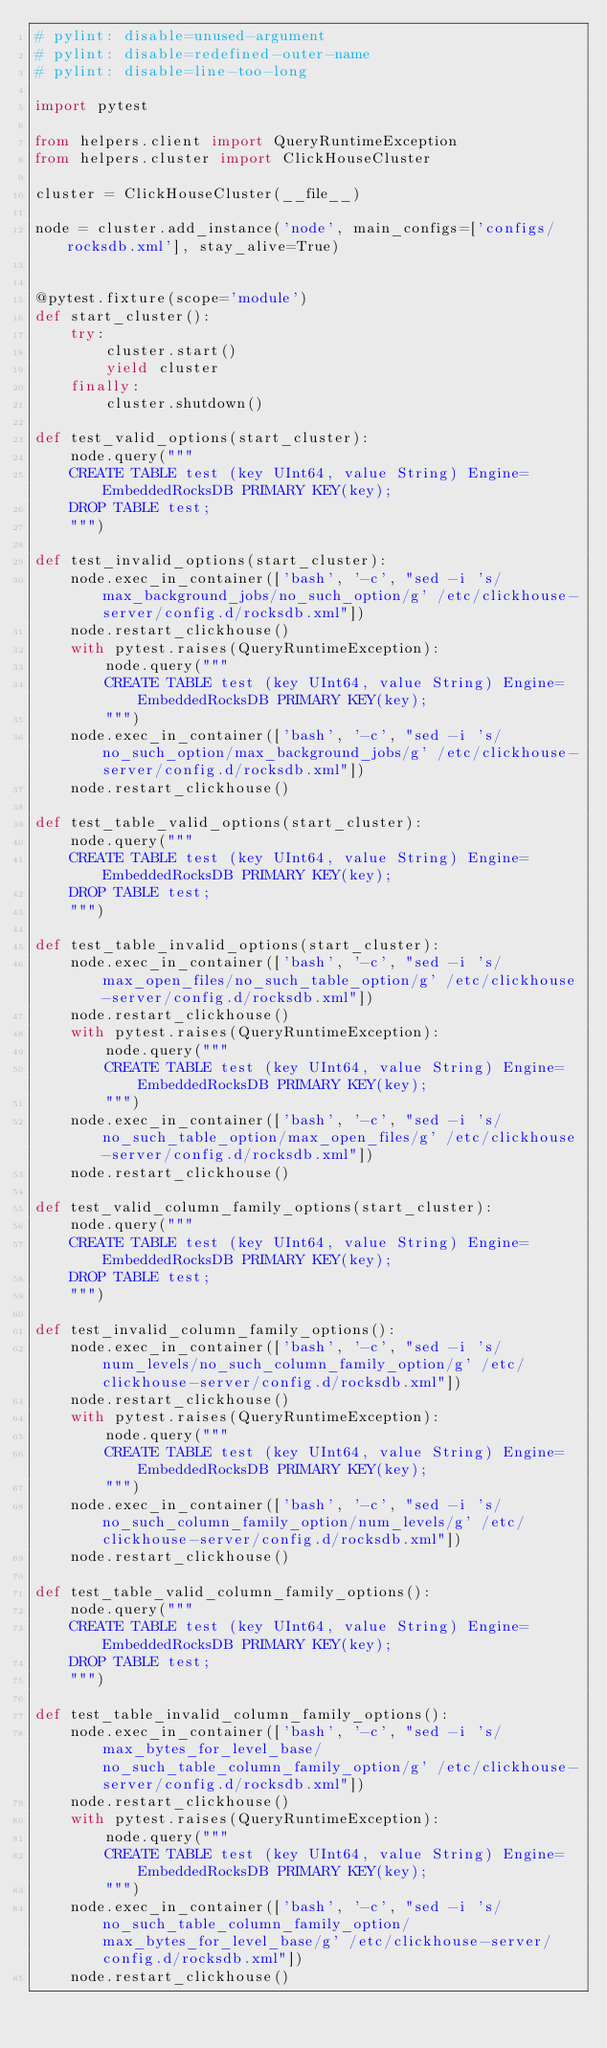<code> <loc_0><loc_0><loc_500><loc_500><_Python_># pylint: disable=unused-argument
# pylint: disable=redefined-outer-name
# pylint: disable=line-too-long

import pytest

from helpers.client import QueryRuntimeException
from helpers.cluster import ClickHouseCluster

cluster = ClickHouseCluster(__file__)

node = cluster.add_instance('node', main_configs=['configs/rocksdb.xml'], stay_alive=True)


@pytest.fixture(scope='module')
def start_cluster():
    try:
        cluster.start()
        yield cluster
    finally:
        cluster.shutdown()

def test_valid_options(start_cluster):
    node.query("""
    CREATE TABLE test (key UInt64, value String) Engine=EmbeddedRocksDB PRIMARY KEY(key);
    DROP TABLE test;
    """)

def test_invalid_options(start_cluster):
    node.exec_in_container(['bash', '-c', "sed -i 's/max_background_jobs/no_such_option/g' /etc/clickhouse-server/config.d/rocksdb.xml"])
    node.restart_clickhouse()
    with pytest.raises(QueryRuntimeException):
        node.query("""
        CREATE TABLE test (key UInt64, value String) Engine=EmbeddedRocksDB PRIMARY KEY(key);
        """)
    node.exec_in_container(['bash', '-c', "sed -i 's/no_such_option/max_background_jobs/g' /etc/clickhouse-server/config.d/rocksdb.xml"])
    node.restart_clickhouse()

def test_table_valid_options(start_cluster):
    node.query("""
    CREATE TABLE test (key UInt64, value String) Engine=EmbeddedRocksDB PRIMARY KEY(key);
    DROP TABLE test;
    """)

def test_table_invalid_options(start_cluster):
    node.exec_in_container(['bash', '-c', "sed -i 's/max_open_files/no_such_table_option/g' /etc/clickhouse-server/config.d/rocksdb.xml"])
    node.restart_clickhouse()
    with pytest.raises(QueryRuntimeException):
        node.query("""
        CREATE TABLE test (key UInt64, value String) Engine=EmbeddedRocksDB PRIMARY KEY(key);
        """)
    node.exec_in_container(['bash', '-c', "sed -i 's/no_such_table_option/max_open_files/g' /etc/clickhouse-server/config.d/rocksdb.xml"])
    node.restart_clickhouse()

def test_valid_column_family_options(start_cluster):
    node.query("""
    CREATE TABLE test (key UInt64, value String) Engine=EmbeddedRocksDB PRIMARY KEY(key);
    DROP TABLE test;
    """)

def test_invalid_column_family_options():
    node.exec_in_container(['bash', '-c', "sed -i 's/num_levels/no_such_column_family_option/g' /etc/clickhouse-server/config.d/rocksdb.xml"])
    node.restart_clickhouse()
    with pytest.raises(QueryRuntimeException):
        node.query("""
        CREATE TABLE test (key UInt64, value String) Engine=EmbeddedRocksDB PRIMARY KEY(key);
        """)
    node.exec_in_container(['bash', '-c', "sed -i 's/no_such_column_family_option/num_levels/g' /etc/clickhouse-server/config.d/rocksdb.xml"])
    node.restart_clickhouse()

def test_table_valid_column_family_options():
    node.query("""
    CREATE TABLE test (key UInt64, value String) Engine=EmbeddedRocksDB PRIMARY KEY(key);
    DROP TABLE test;
    """)

def test_table_invalid_column_family_options():
    node.exec_in_container(['bash', '-c', "sed -i 's/max_bytes_for_level_base/no_such_table_column_family_option/g' /etc/clickhouse-server/config.d/rocksdb.xml"])
    node.restart_clickhouse()
    with pytest.raises(QueryRuntimeException):
        node.query("""
        CREATE TABLE test (key UInt64, value String) Engine=EmbeddedRocksDB PRIMARY KEY(key);
        """)
    node.exec_in_container(['bash', '-c', "sed -i 's/no_such_table_column_family_option/max_bytes_for_level_base/g' /etc/clickhouse-server/config.d/rocksdb.xml"])
    node.restart_clickhouse()
</code> 